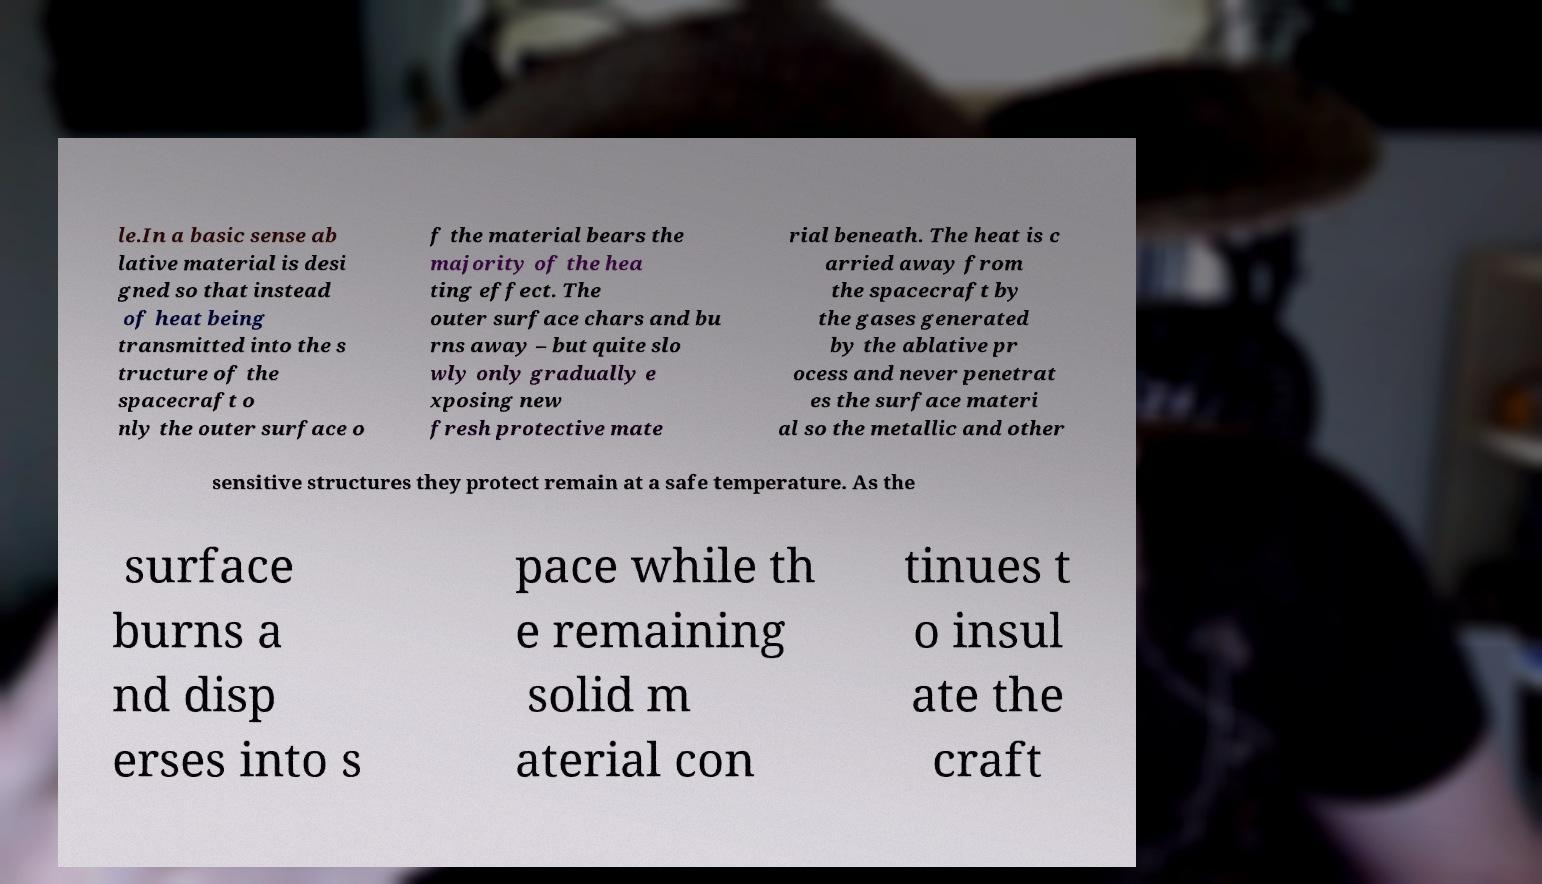I need the written content from this picture converted into text. Can you do that? le.In a basic sense ab lative material is desi gned so that instead of heat being transmitted into the s tructure of the spacecraft o nly the outer surface o f the material bears the majority of the hea ting effect. The outer surface chars and bu rns away – but quite slo wly only gradually e xposing new fresh protective mate rial beneath. The heat is c arried away from the spacecraft by the gases generated by the ablative pr ocess and never penetrat es the surface materi al so the metallic and other sensitive structures they protect remain at a safe temperature. As the surface burns a nd disp erses into s pace while th e remaining solid m aterial con tinues t o insul ate the craft 